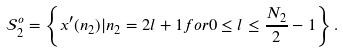Convert formula to latex. <formula><loc_0><loc_0><loc_500><loc_500>\mathcal { S } ^ { o } _ { 2 } = \left \{ x ^ { \prime } ( n _ { 2 } ) | n _ { 2 } = 2 l + 1 f o r 0 \leq l \leq \frac { N _ { 2 } } { 2 } - 1 \right \} .</formula> 